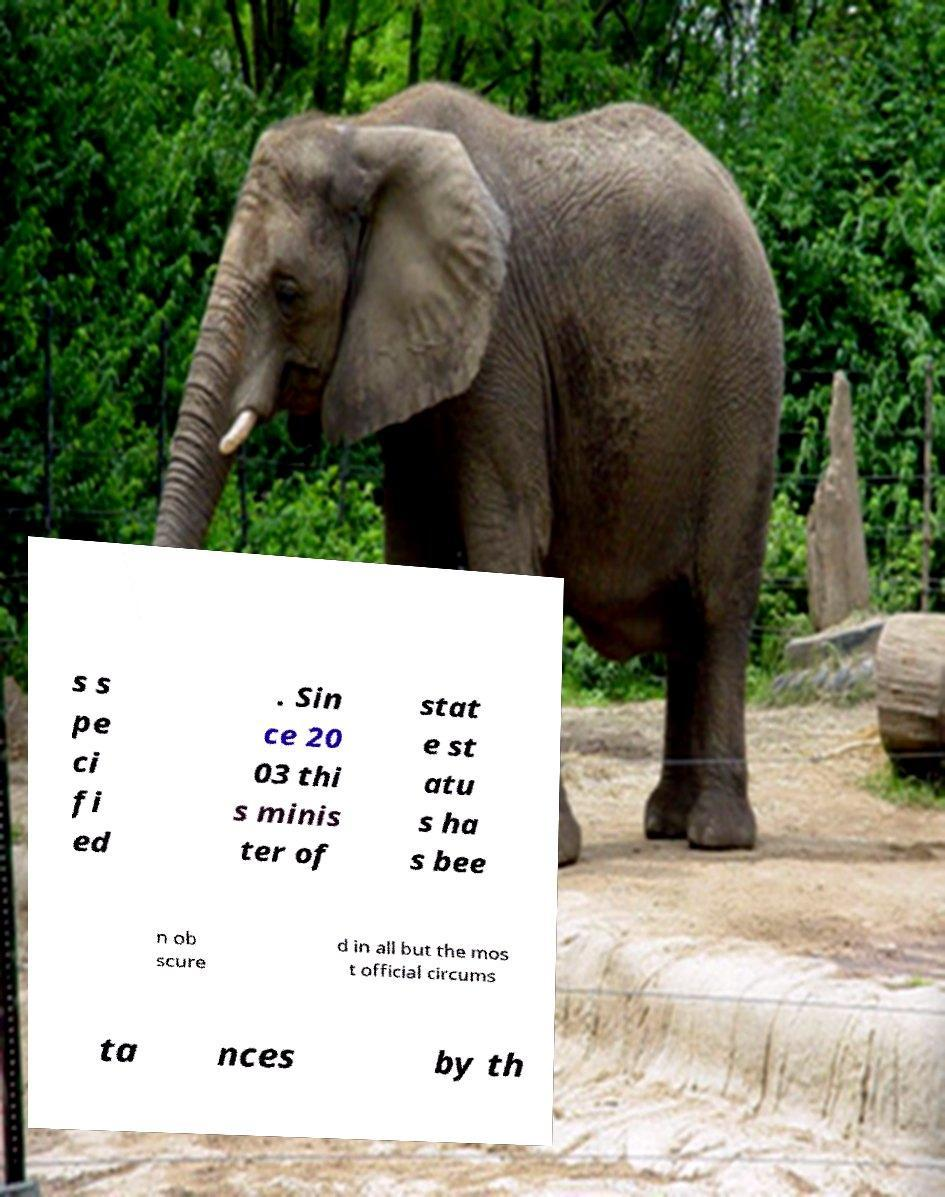Please identify and transcribe the text found in this image. s s pe ci fi ed . Sin ce 20 03 thi s minis ter of stat e st atu s ha s bee n ob scure d in all but the mos t official circums ta nces by th 